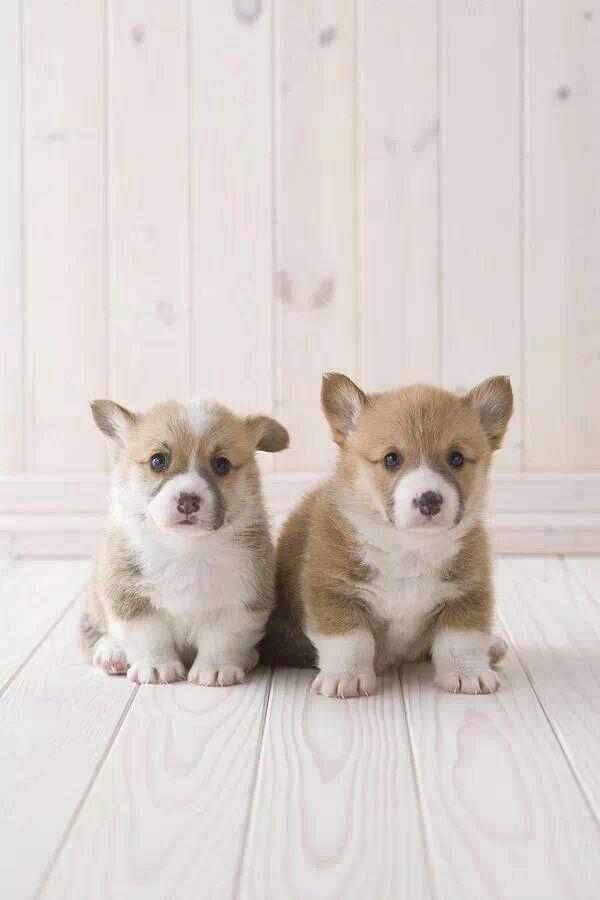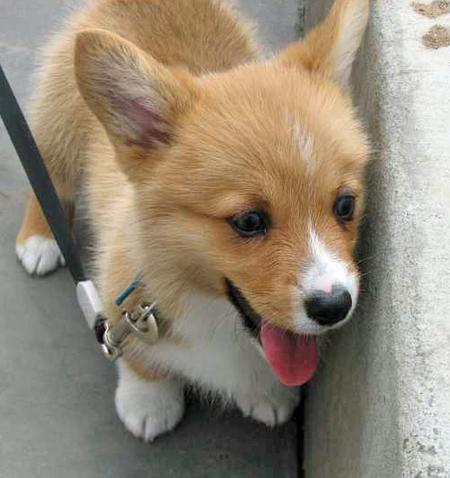The first image is the image on the left, the second image is the image on the right. Considering the images on both sides, is "There is at least three dogs." valid? Answer yes or no. Yes. The first image is the image on the left, the second image is the image on the right. Considering the images on both sides, is "One image contains two dogs, sitting on a wooden slat deck or floor, while no image in the set contains green grass." valid? Answer yes or no. Yes. 